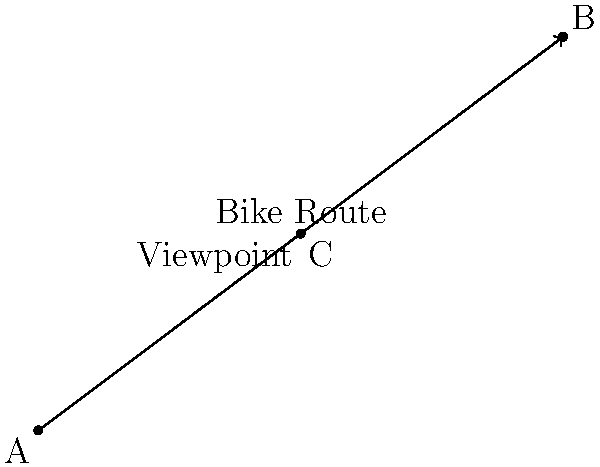In planning a scenic bike route, you need to determine the perpendicular distance from a viewpoint to the proposed route. Given that the bike route is represented by vector $\vec{AB}$ from point A(0,0) to B(8,6), and the viewpoint is at point C(4,3), calculate the perpendicular distance from point C to the bike route using the cross product method. To find the perpendicular distance from point C to the bike route AB, we can use the cross product method. Here's the step-by-step solution:

1) First, we need to calculate the vectors $\vec{AB}$ and $\vec{AC}$:
   $\vec{AB} = (8-0, 6-0) = (8, 6)$
   $\vec{AC} = (4-0, 3-0) = (4, 3)$

2) The magnitude of the cross product of these vectors divided by the magnitude of $\vec{AB}$ will give us the perpendicular distance:

   Distance = $\frac{|\vec{AB} \times \vec{AC}|}{|\vec{AB}|}$

3) Calculate the cross product $\vec{AB} \times \vec{AC}$:
   $\vec{AB} \times \vec{AC} = (8 \cdot 3) - (6 \cdot 4) = 24 - 24 = 0$

4) Calculate the magnitude of $\vec{AB}$:
   $|\vec{AB}| = \sqrt{8^2 + 6^2} = \sqrt{64 + 36} = \sqrt{100} = 10$

5) Now, we can calculate the distance:
   Distance = $\frac{|0|}{10} = 0$

The perpendicular distance from point C to the bike route AB is 0, which means point C lies on the bike route.
Answer: 0 